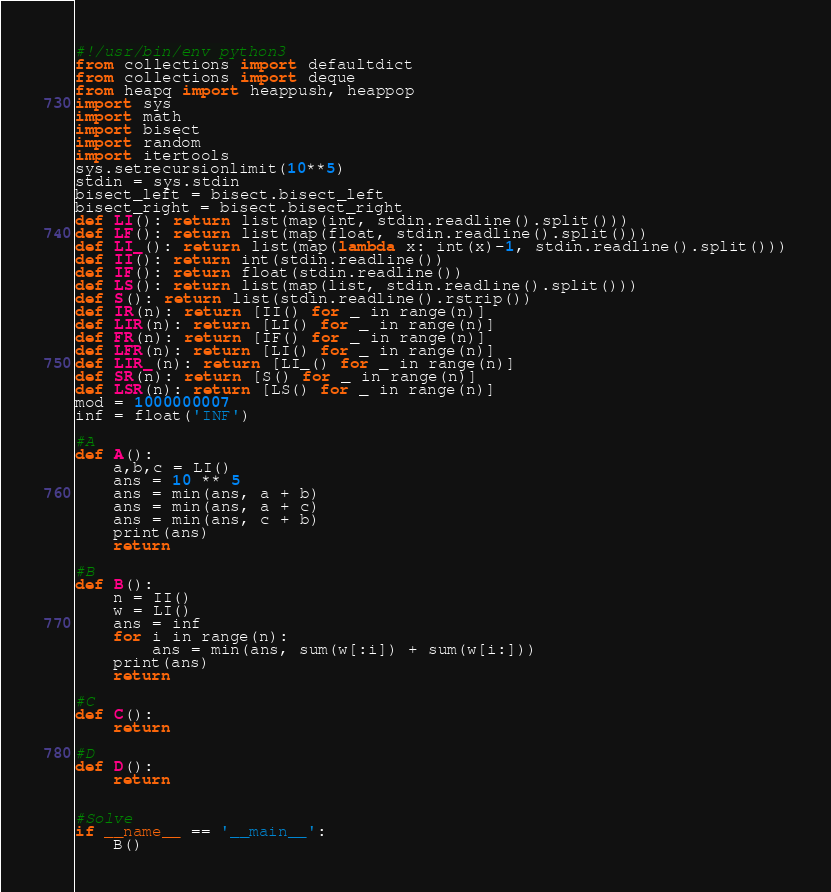Convert code to text. <code><loc_0><loc_0><loc_500><loc_500><_Python_>#!/usr/bin/env python3
from collections import defaultdict
from collections import deque
from heapq import heappush, heappop
import sys
import math
import bisect
import random
import itertools
sys.setrecursionlimit(10**5)
stdin = sys.stdin
bisect_left = bisect.bisect_left
bisect_right = bisect.bisect_right
def LI(): return list(map(int, stdin.readline().split()))
def LF(): return list(map(float, stdin.readline().split()))
def LI_(): return list(map(lambda x: int(x)-1, stdin.readline().split()))
def II(): return int(stdin.readline())
def IF(): return float(stdin.readline())
def LS(): return list(map(list, stdin.readline().split()))
def S(): return list(stdin.readline().rstrip())
def IR(n): return [II() for _ in range(n)]
def LIR(n): return [LI() for _ in range(n)]
def FR(n): return [IF() for _ in range(n)]
def LFR(n): return [LI() for _ in range(n)]
def LIR_(n): return [LI_() for _ in range(n)]
def SR(n): return [S() for _ in range(n)]
def LSR(n): return [LS() for _ in range(n)]
mod = 1000000007
inf = float('INF')

#A
def A():
    a,b,c = LI()
    ans = 10 ** 5
    ans = min(ans, a + b)
    ans = min(ans, a + c)
    ans = min(ans, c + b)
    print(ans)
    return

#B
def B():
    n = II()
    w = LI()
    ans = inf
    for i in range(n):
        ans = min(ans, sum(w[:i]) + sum(w[i:]))
    print(ans)
    return

#C
def C():
    return

#D
def D():
    return


#Solve
if __name__ == '__main__':
    B()
</code> 